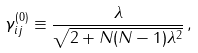Convert formula to latex. <formula><loc_0><loc_0><loc_500><loc_500>\gamma _ { i j } ^ { ( 0 ) } \equiv \frac { \lambda } { \sqrt { 2 + N ( N - 1 ) \lambda ^ { 2 } } } \, ,</formula> 